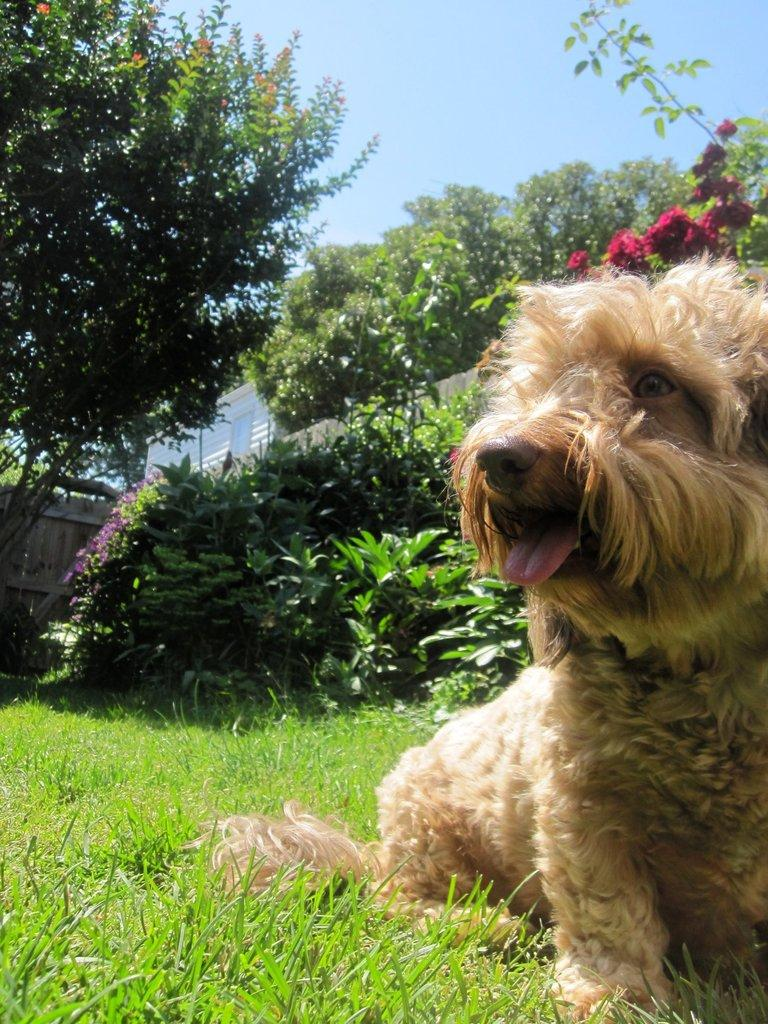What type of animal can be seen on the grass field in the image? There is a dog on the grass field in the image. What type of vegetation is present in the image? There are plants, flowers, and trees in the image. What type of barrier can be seen in the image? There is a wooden fence in the image. What type of structure is present in the image? There is a building in the image. What is visible in the sky in the image? The sky is visible in the image and appears cloudy. Where is the nest of the bird in the image? There is no bird or nest present in the image. What type of fuel is being used by the dog in the image? Dogs do not use fuel; they are living beings and do not require fuel to function. 